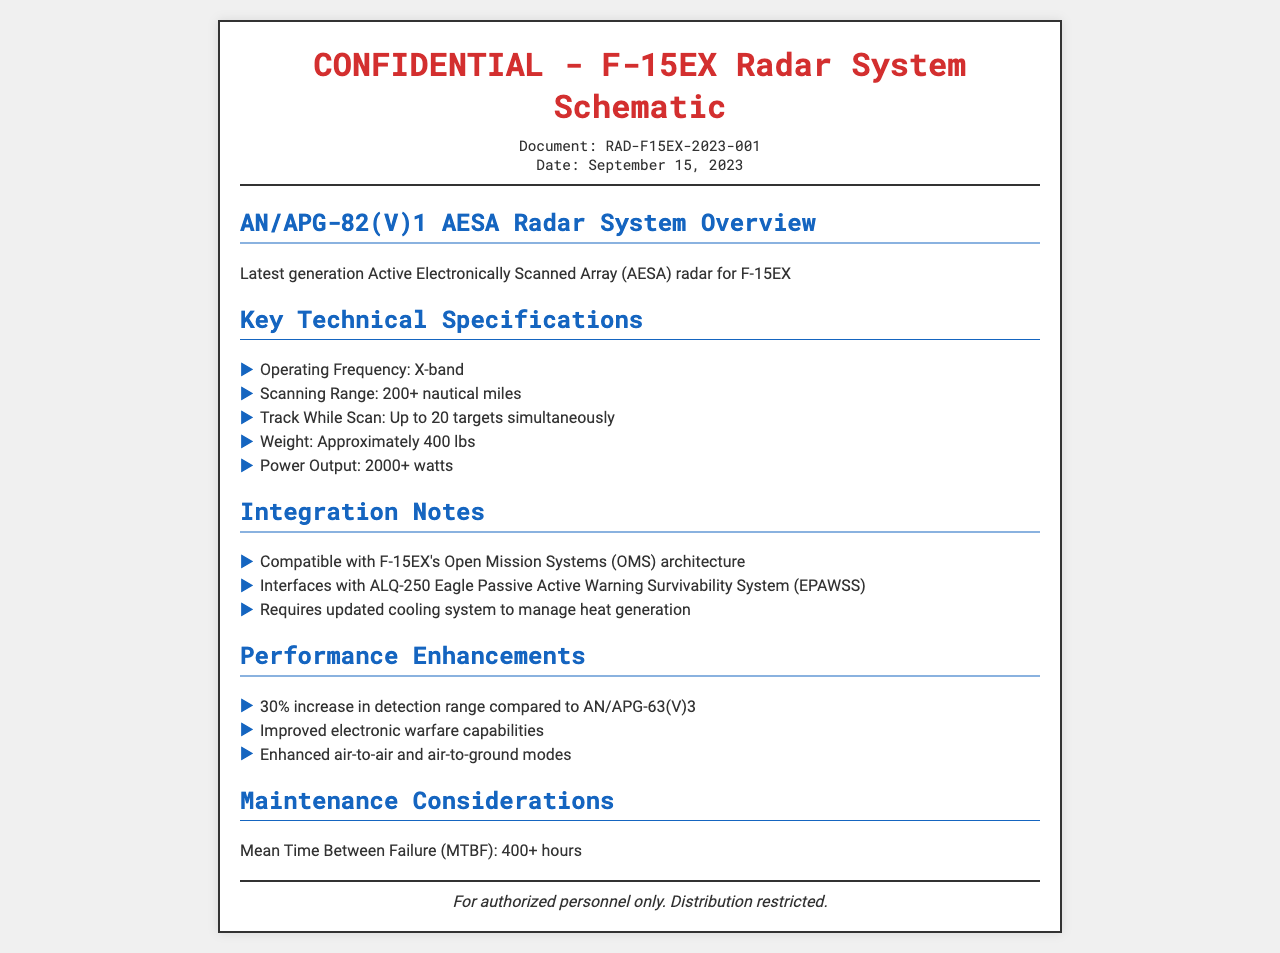What is the document number? The document number is provided in the document header under "Document".
Answer: RAD-F15EX-2023-001 What is the date of the document? The date appears below the document number in the header section.
Answer: September 15, 2023 What is the operating frequency of the radar system? The operating frequency is listed in the "Key Technical Specifications" section of the document.
Answer: X-band How many targets can the radar track simultaneously? This information is specified in the "Key Technical Specifications" section under "Track While Scan".
Answer: Up to 20 targets What is the weight of the radar system? The weight is mentioned under the "Key Technical Specifications" section.
Answer: Approximately 400 lbs What is the increase in detection range compared to the AN/APG-63(V)3? The percentage increase is detailed in the "Performance Enhancements" section of the document.
Answer: 30% What cooling system requirement is mentioned for the radar? This requirement is found in the "Integration Notes" section of the document.
Answer: Requires updated cooling system What is the Mean Time Between Failure (MTBF) for the radar system? The MTBF is specified in the "Maintenance Considerations" section.
Answer: 400+ hours Who is the document intended for? This information is noted in the footer at the bottom of the document.
Answer: Authorized personnel only 